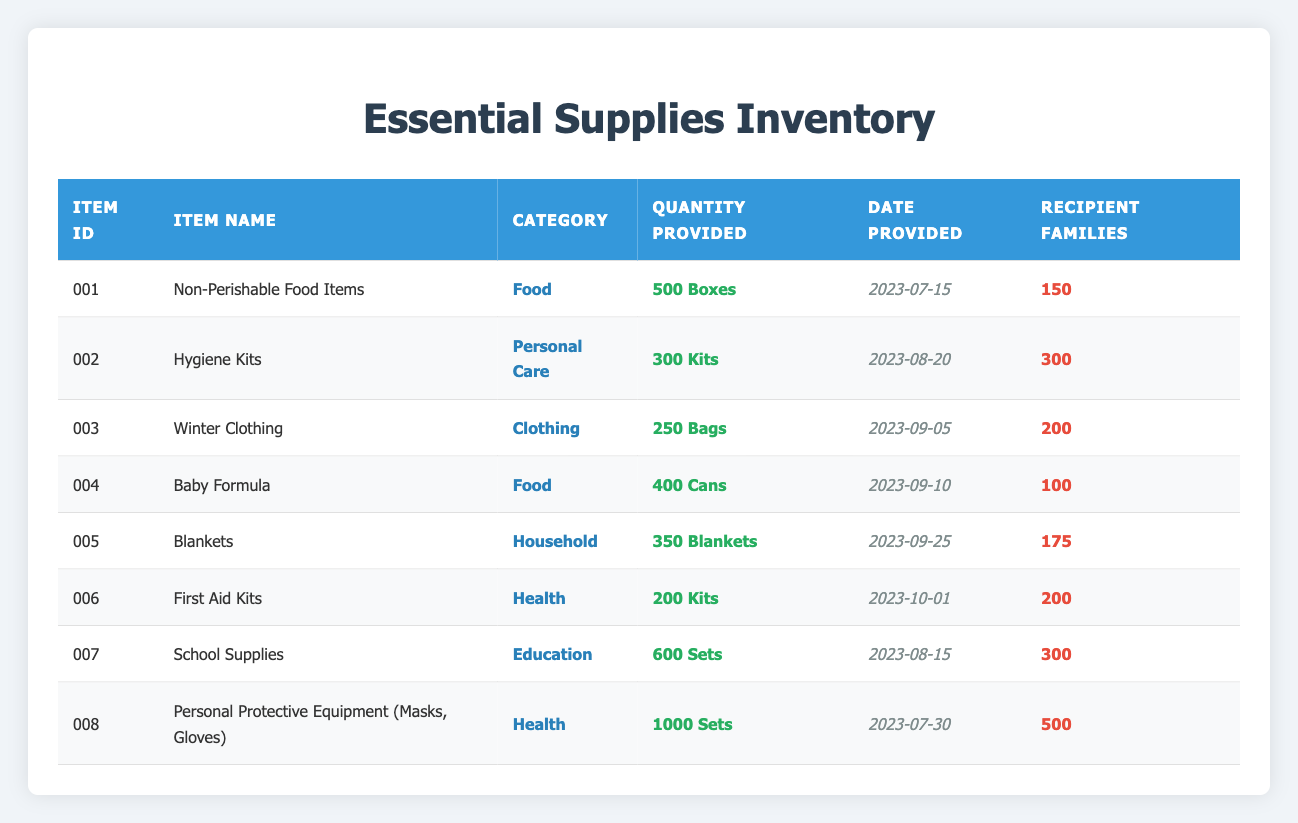What items belong to the Food category? By reviewing the table, I identify items under the 'Category' column labeled as 'Food'. The relevant items are Non-Perishable Food Items and Baby Formula.
Answer: Non-Perishable Food Items, Baby Formula How many Hygiene Kits were provided? Simply look for the 'Hygiene Kits' entry under the 'Quantity Provided' column. It shows that 300 Kits were provided.
Answer: 300 Kits What is the total number of families that received essential supplies? To derive the total, I sum the 'Recipient Families' column values: 150 + 300 + 200 + 100 + 175 + 200 + 300 + 500 = 1925 families received supplies.
Answer: 1925 families Which item had the highest quantity provided? I compare the numbers in the 'Quantity Provided' column: 500 (Non-Perishable Food Items), 300 (Hygiene Kits), 250 (Winter Clothing), 400 (Baby Formula), 350 (Blankets), 200 (First Aid Kits), 600 (School Supplies), 1000 (Personal Protective Equipment). The highest is 1000 for Personal Protective Equipment.
Answer: Personal Protective Equipment (Masks, Gloves) Did more families receive School Supplies or Hygiene Kits? I check the 'Recipient Families' for both items: School Supplies had 300 families, and Hygiene Kits had 300 families. They are equal, so no one had more.
Answer: No (they have the same number) What is the average quantity of items distributed across all categories? First, I sum all the quantities provided: 500 + 300 + 250 + 400 + 350 + 200 + 600 + 1000 = 3100. Since there are 8 items, I divide 3100 by 8 to find the average, which is 387.5.
Answer: 387.5 How many more sets of Personal Protective Equipment were provided than First Aid Kits? I look at the quantities: Personal Protective Equipment provided 1000 sets and First Aid Kits provided 200 kits. I subtract 200 from 1000 to determine the difference: 1000 - 200 = 800.
Answer: 800 Was Baby Formula provided before Winter Clothing? I check their respective 'Date Provided' entries: Baby Formula was provided on 2023-09-10 and Winter Clothing on 2023-09-05. September 10 is after September 5, so Baby Formula was provided after Winter Clothing.
Answer: No 